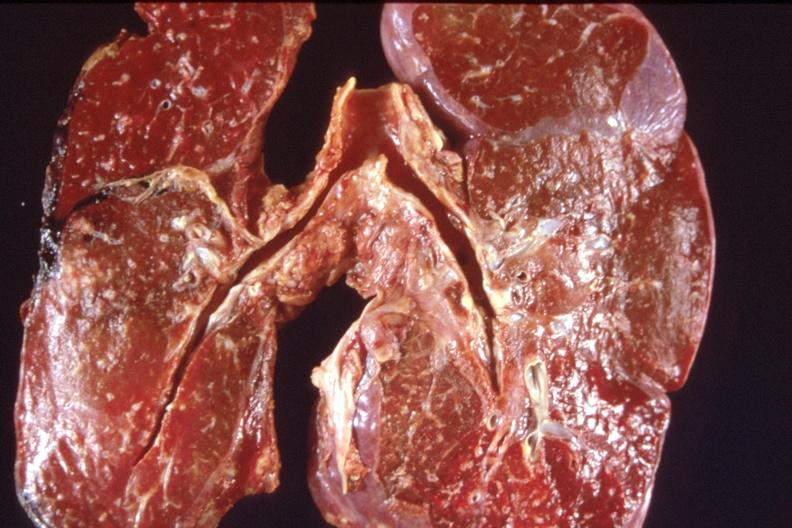where is this?
Answer the question using a single word or phrase. Lung 